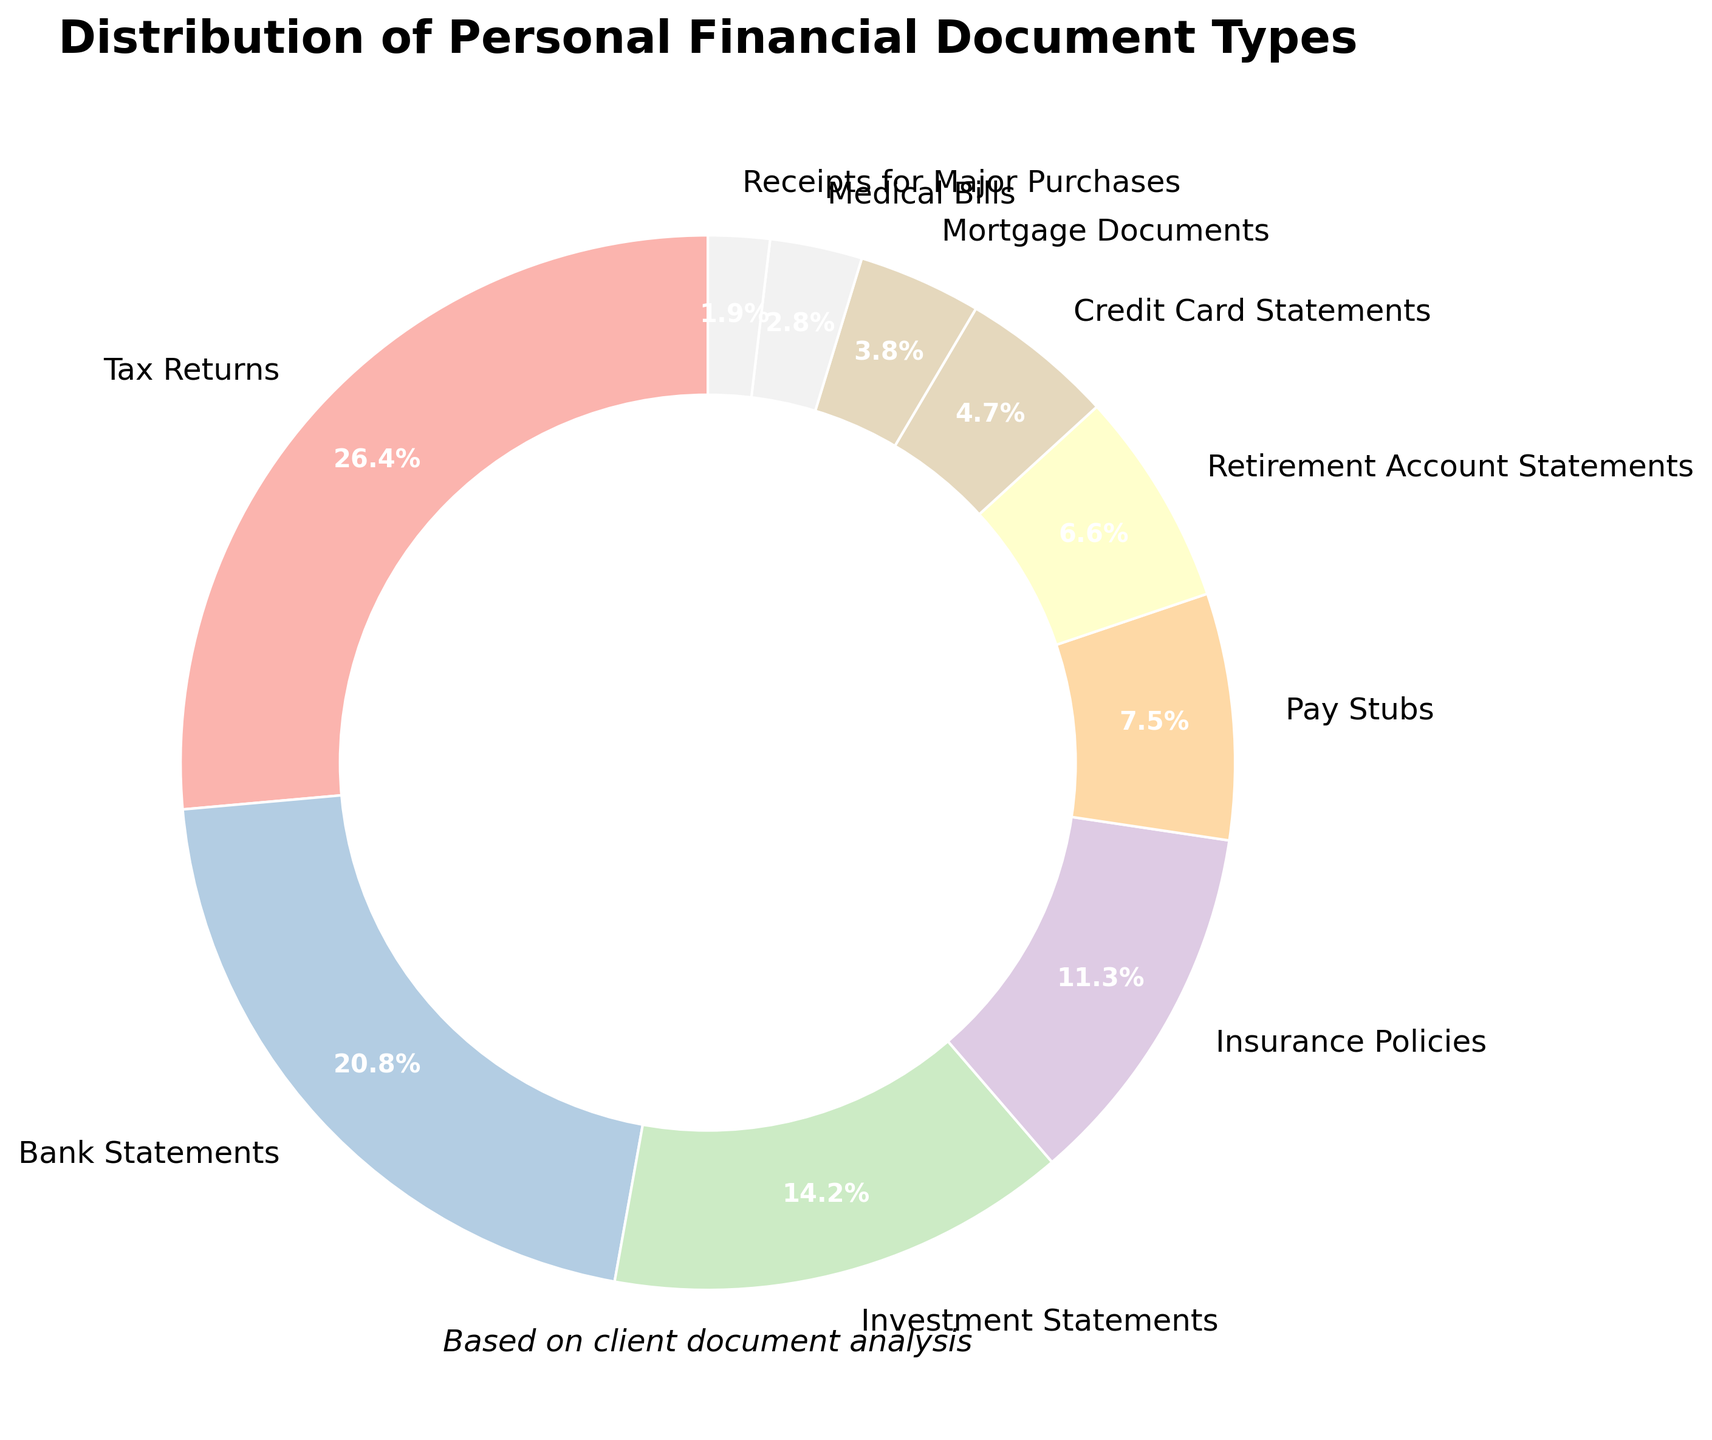What category has the highest percentage in the pie chart? By looking at the labels and percentages on the pie chart, we can see that the category with the highest percentage is 'Tax Returns' at 28%.
Answer: Tax Returns What is the combined percentage of Bank Statements and Investment Statements? The percentage for Bank Statements is 22% and for Investment Statements is 15%. Adding these together, 22% + 15% = 37%.
Answer: 37% Which category has the smallest percentage? By observing the smallest segment in the pie chart, we can see that 'Receipts for Major Purchases' has the smallest percentage at 2%.
Answer: Receipts for Major Purchases How much more is the percentage of Tax Returns compared to Medical Bills? The percentage for Tax Returns is 28% and for Medical Bills is 3%. The difference is 28% - 3% = 25%.
Answer: 25% If we combine the percentages for Insurance Policies, Pay Stubs, and Mortgage Documents, what is the total percentage? The percentages are 12% for Insurance Policies, 8% for Pay Stubs, and 4% for Mortgage Documents. Adding these together, 12% + 8% + 4% = 24%.
Answer: 24% What is the ratio of Pay Stubs to Credit Card Statements? The percentage for Pay Stubs is 8% and for Credit Card Statements is 5%. The ratio is 8% to 5%, which simplifies to 8:5.
Answer: 8:5 Which categories combined make up more than half of the total percentage? By adding the highest percentages, we find that Tax Returns (28%), Bank Statements (22%), and Investment Statements (15%) add up to 28% + 22% + 15% = 65%, which is more than half (50%).
Answer: Tax Returns, Bank Statements, Investment Statements Ranking the categories from highest to lowest percentage, what position does Retirement Account Statements hold? The percentages from highest to lowest are: Tax Returns (28%), Bank Statements (22%), Investment Statements (15%), Insurance Policies (12%), Pay Stubs (8%), Retirement Account Statements (7%), Credit Card Statements (5%), Mortgage Documents (4%), Medical Bills (3%), Receipts for Major Purchases (2%). Retirement Account Statements is in the 6th position.
Answer: 6th What is the difference in percentage between the highest and the lowest category? The highest category is Tax Returns at 28% and the lowest is Receipts for Major Purchases at 2%. The difference is 28% - 2% = 26%.
Answer: 26% How many categories have a percentage equal to or greater than 10%? The categories with percentages equal to or greater than 10% are Tax Returns (28%), Bank Statements (22%), and Investment Statements (15%), and Insurance Policies (12%). That totals to 4 categories.
Answer: 4 